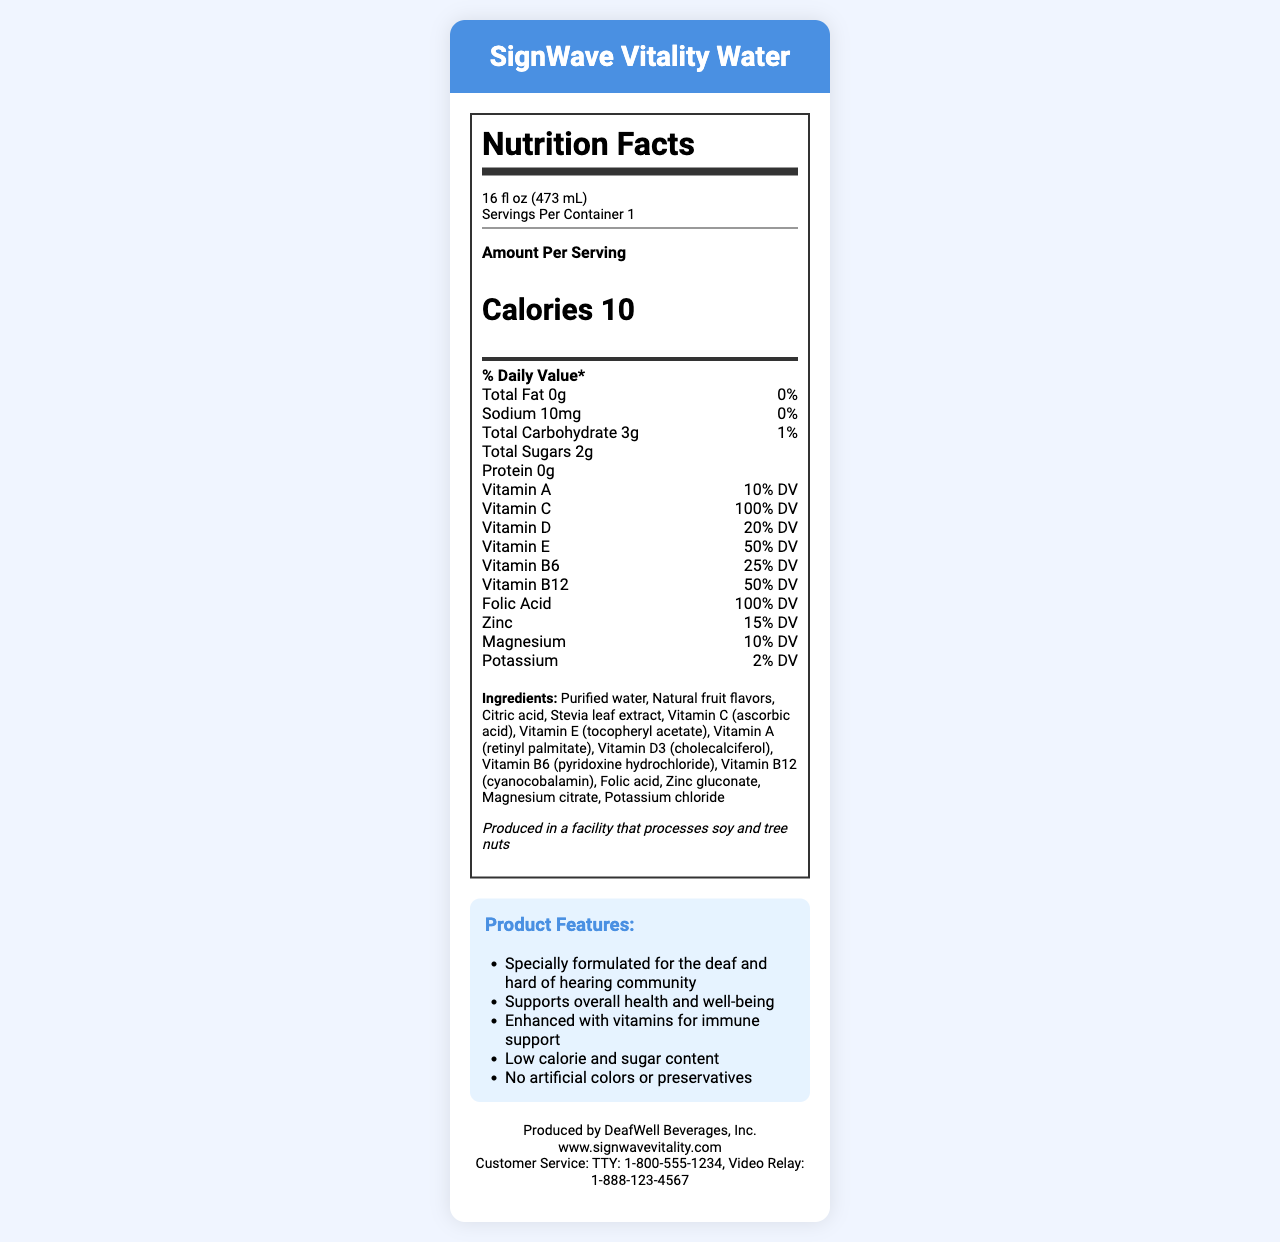what is the serving size of the SignWave Vitality Water? The serving size is listed at the beginning of the nutrition label.
Answer: 16 fl oz (473 mL) how many calories are in one serving of SignWave Vitality Water? The calorie content is prominently displayed in the middle of the nutrition facts section.
Answer: 10 which vitamin is present at 100% of the daily value? Both Vitamin C and Folic Acid are listed as 100% DV in the nutrition facts section.
Answer: Vitamin C and Folic Acid what is the sodium content per serving? The sodium content is listed under the total fat in the nutrition facts section.
Answer: 10mg list three ingredients used in SignWave Vitality Water. The ingredient list includes these items among others.
Answer: Purified water, Natural fruit flavors, Citric acid how much total fat is in SignWave Vitality Water? The total fat is listed as 0g in the nutrition facts section.
Answer: 0g what type of packaging is used for SignWave Vitality Water? This information is listed under the packaging section towards the end of the document.
Answer: BPA-free, recyclable plastic bottle with easy-grip design which company produces SignWave Vitality Water? A. SignWell Inc B. VitalWater Ltd C. DeafWell Beverages, Inc D. HealthWave Corp The document states that DeafWell Beverages, Inc. is the producer.
Answer: C. DeafWell Beverages, Inc what is the percentage Daily Value (% DV) of zinc in the beverage? A. 5% B. 15% C. 50% D. 100% The % DV of zinc is listed as 15% in the nutrition facts section.
Answer: B. 15% is SignWave Vitality Water free from artificial colors and preservatives? This claim is made in the marketing section of the document.
Answer: Yes summarize the main idea of the document. The overall content covers the nutritional facts, serving size, vitamins included, ingredients, allergen information, packaging, and contact details, giving a comprehensive overview of the product.
Answer: The document provides the nutritional information, ingredients, marketing claims, and company details about SignWave Vitality Water, a vitamin-fortified beverage specially formulated for the deaf community. is the SignWave Vitality Water a high-calorie beverage? The beverage only contains 10 calories per serving, which is considered low in calories.
Answer: No can we determine the color of SignWave Vitality Water from the document? The document does not provide any information about the color of the beverage.
Answer: Not enough information 